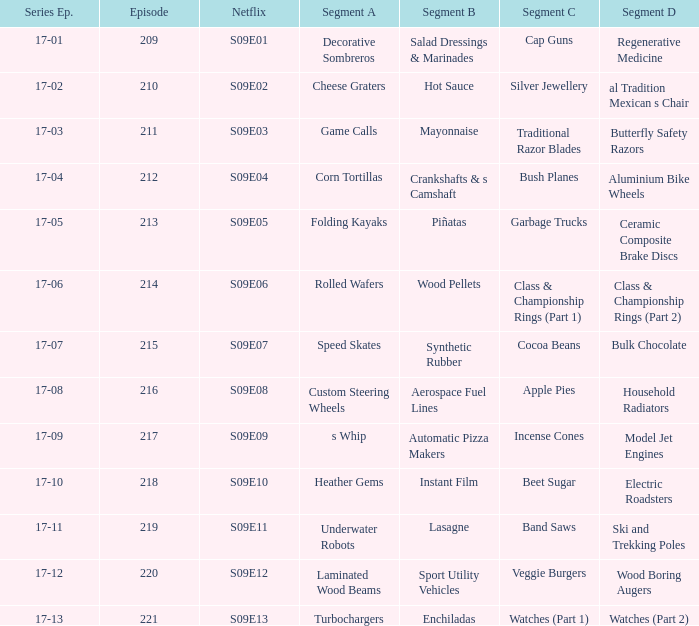Segment A of heather gems is what netflix episode? S09E10. 